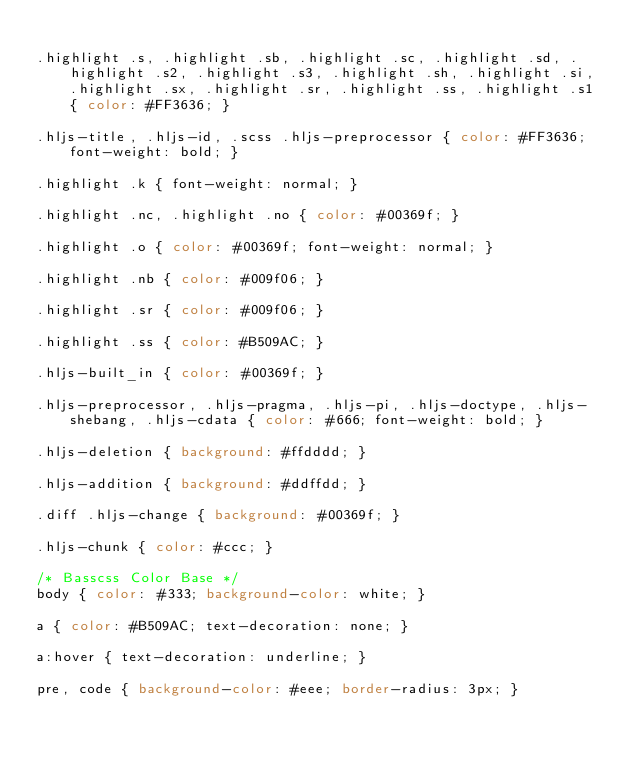<code> <loc_0><loc_0><loc_500><loc_500><_CSS_>
.highlight .s, .highlight .sb, .highlight .sc, .highlight .sd, .highlight .s2, .highlight .s3, .highlight .sh, .highlight .si, .highlight .sx, .highlight .sr, .highlight .ss, .highlight .s1 { color: #FF3636; }

.hljs-title, .hljs-id, .scss .hljs-preprocessor { color: #FF3636; font-weight: bold; }

.highlight .k { font-weight: normal; }

.highlight .nc, .highlight .no { color: #00369f; }

.highlight .o { color: #00369f; font-weight: normal; }

.highlight .nb { color: #009f06; }

.highlight .sr { color: #009f06; }

.highlight .ss { color: #B509AC; }

.hljs-built_in { color: #00369f; }

.hljs-preprocessor, .hljs-pragma, .hljs-pi, .hljs-doctype, .hljs-shebang, .hljs-cdata { color: #666; font-weight: bold; }

.hljs-deletion { background: #ffdddd; }

.hljs-addition { background: #ddffdd; }

.diff .hljs-change { background: #00369f; }

.hljs-chunk { color: #ccc; }

/* Basscss Color Base */
body { color: #333; background-color: white; }

a { color: #B509AC; text-decoration: none; }

a:hover { text-decoration: underline; }

pre, code { background-color: #eee; border-radius: 3px; }
</code> 